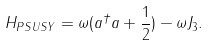Convert formula to latex. <formula><loc_0><loc_0><loc_500><loc_500>H _ { P S U S Y } = \omega ( a ^ { \dag } a + \frac { 1 } { 2 } ) - \omega J _ { 3 } .</formula> 